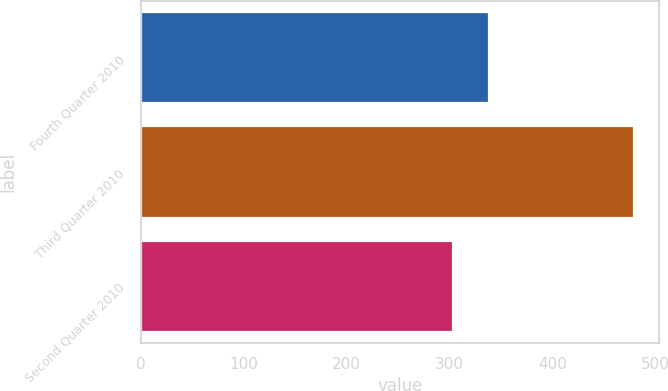Convert chart to OTSL. <chart><loc_0><loc_0><loc_500><loc_500><bar_chart><fcel>Fourth Quarter 2010<fcel>Third Quarter 2010<fcel>Second Quarter 2010<nl><fcel>338<fcel>479<fcel>303<nl></chart> 